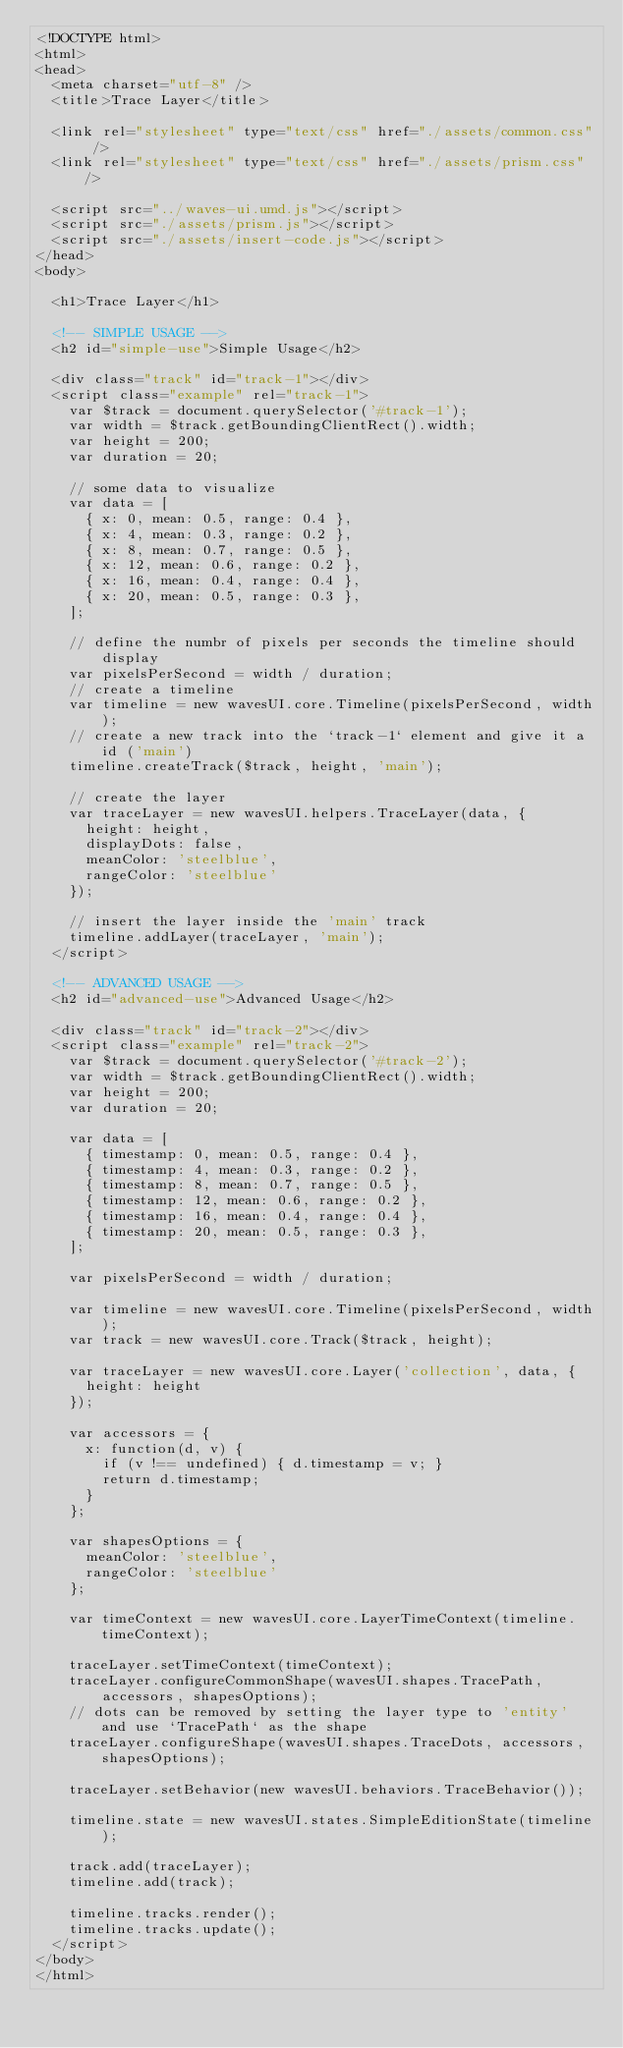<code> <loc_0><loc_0><loc_500><loc_500><_HTML_><!DOCTYPE html>
<html>
<head>
  <meta charset="utf-8" />
  <title>Trace Layer</title>

  <link rel="stylesheet" type="text/css" href="./assets/common.css" />
  <link rel="stylesheet" type="text/css" href="./assets/prism.css" />

  <script src="../waves-ui.umd.js"></script>
  <script src="./assets/prism.js"></script>
  <script src="./assets/insert-code.js"></script>
</head>
<body>

  <h1>Trace Layer</h1>

  <!-- SIMPLE USAGE -->
  <h2 id="simple-use">Simple Usage</h2>

  <div class="track" id="track-1"></div>
  <script class="example" rel="track-1">
    var $track = document.querySelector('#track-1');
    var width = $track.getBoundingClientRect().width;
    var height = 200;
    var duration = 20;

    // some data to visualize
    var data = [
      { x: 0, mean: 0.5, range: 0.4 },
      { x: 4, mean: 0.3, range: 0.2 },
      { x: 8, mean: 0.7, range: 0.5 },
      { x: 12, mean: 0.6, range: 0.2 },
      { x: 16, mean: 0.4, range: 0.4 },
      { x: 20, mean: 0.5, range: 0.3 },
    ];

    // define the numbr of pixels per seconds the timeline should display
    var pixelsPerSecond = width / duration;
    // create a timeline
    var timeline = new wavesUI.core.Timeline(pixelsPerSecond, width);
    // create a new track into the `track-1` element and give it a id ('main')
    timeline.createTrack($track, height, 'main');

    // create the layer
    var traceLayer = new wavesUI.helpers.TraceLayer(data, {
      height: height,
      displayDots: false,
      meanColor: 'steelblue',
      rangeColor: 'steelblue'
    });

    // insert the layer inside the 'main' track
    timeline.addLayer(traceLayer, 'main');
  </script>

  <!-- ADVANCED USAGE -->
  <h2 id="advanced-use">Advanced Usage</h2>

  <div class="track" id="track-2"></div>
  <script class="example" rel="track-2">
    var $track = document.querySelector('#track-2');
    var width = $track.getBoundingClientRect().width;
    var height = 200;
    var duration = 20;

    var data = [
      { timestamp: 0, mean: 0.5, range: 0.4 },
      { timestamp: 4, mean: 0.3, range: 0.2 },
      { timestamp: 8, mean: 0.7, range: 0.5 },
      { timestamp: 12, mean: 0.6, range: 0.2 },
      { timestamp: 16, mean: 0.4, range: 0.4 },
      { timestamp: 20, mean: 0.5, range: 0.3 },
    ];

    var pixelsPerSecond = width / duration;

    var timeline = new wavesUI.core.Timeline(pixelsPerSecond, width);
    var track = new wavesUI.core.Track($track, height);

    var traceLayer = new wavesUI.core.Layer('collection', data, {
      height: height
    });

    var accessors = {
      x: function(d, v) {
        if (v !== undefined) { d.timestamp = v; }
        return d.timestamp;
      }
    };

    var shapesOptions = {
      meanColor: 'steelblue',
      rangeColor: 'steelblue'
    };

    var timeContext = new wavesUI.core.LayerTimeContext(timeline.timeContext);

    traceLayer.setTimeContext(timeContext);
    traceLayer.configureCommonShape(wavesUI.shapes.TracePath, accessors, shapesOptions);
    // dots can be removed by setting the layer type to 'entity' and use `TracePath` as the shape
    traceLayer.configureShape(wavesUI.shapes.TraceDots, accessors, shapesOptions);

    traceLayer.setBehavior(new wavesUI.behaviors.TraceBehavior());

    timeline.state = new wavesUI.states.SimpleEditionState(timeline);

    track.add(traceLayer);
    timeline.add(track);

    timeline.tracks.render();
    timeline.tracks.update();
  </script>
</body>
</html></code> 